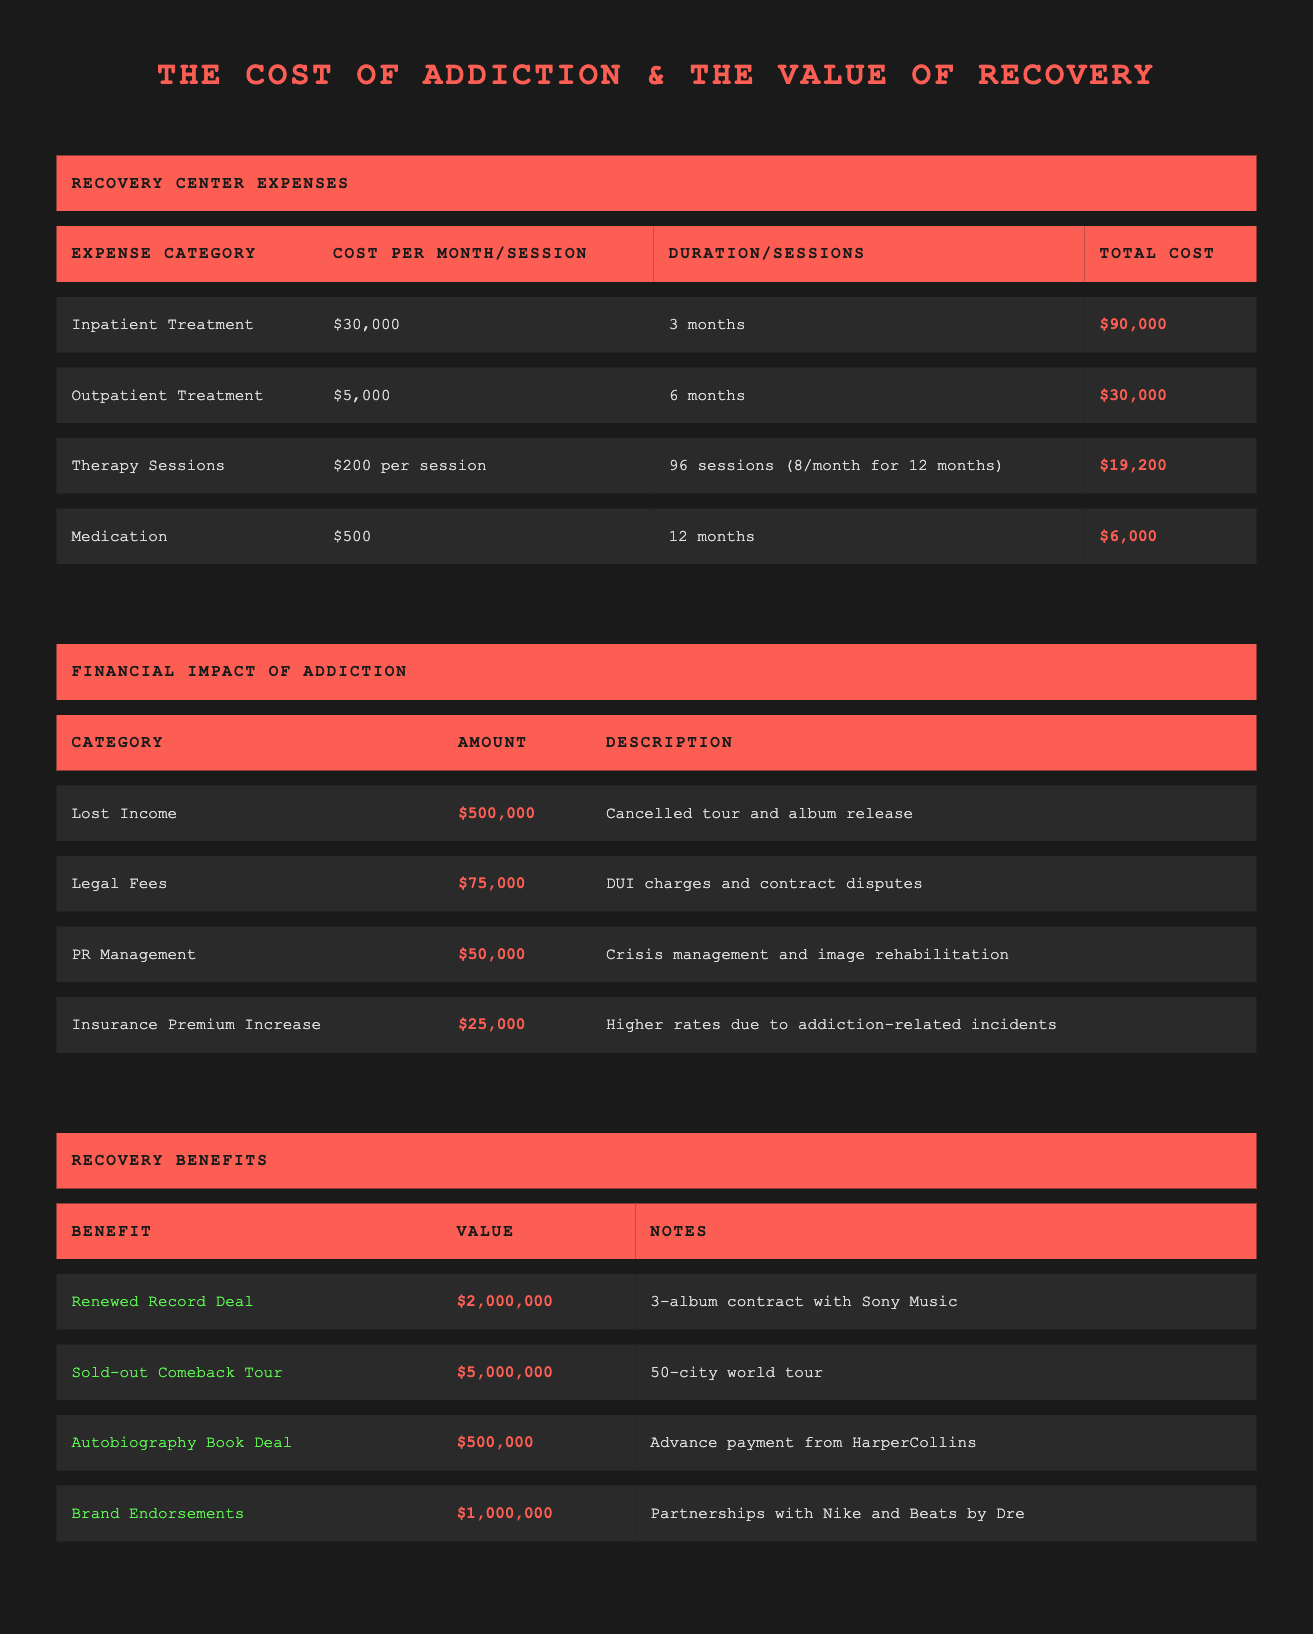What is the total cost of inpatient treatment? The total cost for inpatient treatment is specified directly in the table under the "Total Cost" column for this category. It shows a total of $90,000.
Answer: 90000 How much does outpatient treatment cost per month? The table lists the cost per month for outpatient treatment, which is $5,000.
Answer: 5000 What is the combined total cost for therapy sessions and medication? To find the combined total, we add the total cost of therapy sessions ($19,200) and medication ($6,000). Therefore, $19,200 + $6,000 equals $25,200.
Answer: 25200 Did the recovery center expenses exceed $100,000? Adding all recovery center expenses reveals the following: $90,000 (inpatient) + $30,000 (outpatient) + $19,200 (therapy) + $6,000 (medication) equals $145,200, which does exceed $100,000.
Answer: Yes What is the total financial impact of lost income and legal fees combined? The table states that lost income amounts to $500,000 and legal fees amount to $75,000. By adding these two amounts, we get $500,000 + $75,000, resulting in a total of $575,000.
Answer: 575000 Does the financial impact of insurance premium increases exceed $20,000? The amount listed for insurance premium increases is $25,000, which is greater than $20,000, confirming that it does exceed this threshold.
Answer: Yes What is the total value of recovery benefits acquired? We add together all the values of recovery benefits: $2,000,000 (record deal) + $5,000,000 (comeback tour) + $500,000 (book deal) + $1,000,000 (endorsements) equals a total of $8,500,000.
Answer: 8500000 If you subtract the total cost of recovery center expenses from the total recovery benefits, what is the result? The total recovery benefits are $8,500,000 and the total recovery center expenses amount to $145,200. Subtracting these figures results in $8,500,000 - $145,200, which equals $8,354,800.
Answer: 8354800 What was the financial impact of PR management in relation to lost income? The financial impact of PR management is $50,000, while the lost income is $500,000. To compare, $50,000 is significantly less than $500,000, indicating that PR management costs are a small fraction of lost income.
Answer: Less than lost income 